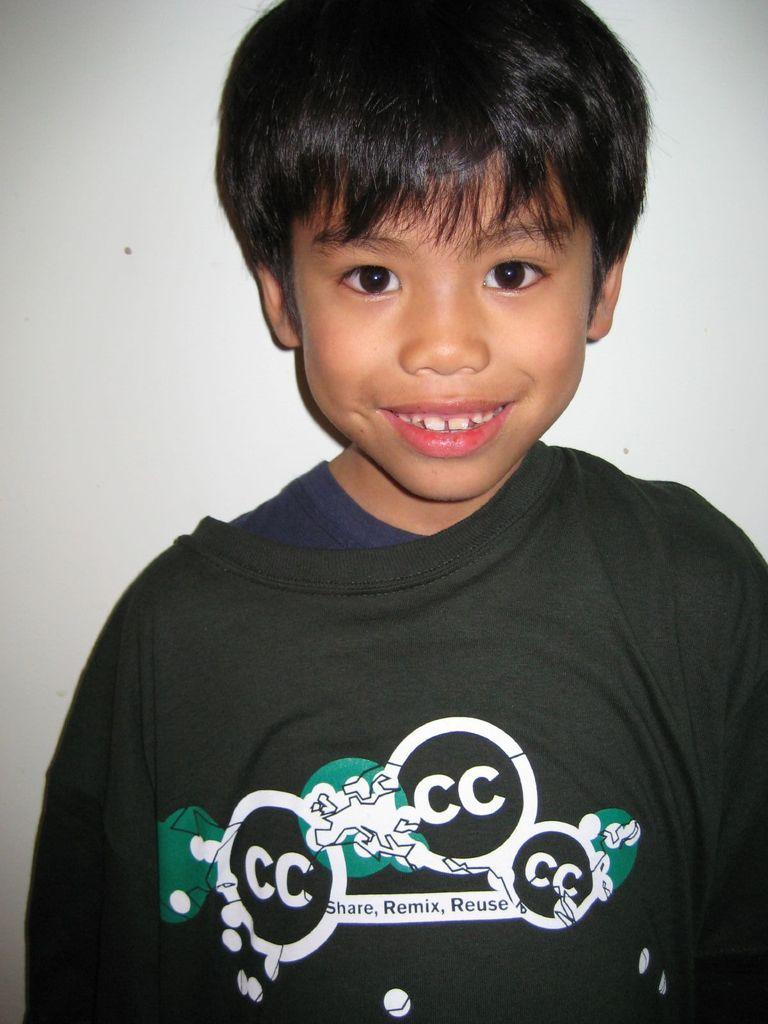Who is present in the image? There is a boy in the image. What expression does the boy have? The boy is smiling. What color is the background of the image? The background of the image is white. What type of quill is the boy holding in the image? There is no quill present in the image; the boy is not holding any object. Can you see a giraffe or bear in the image? No, there are no animals, including giraffes or bears, present in the image. 